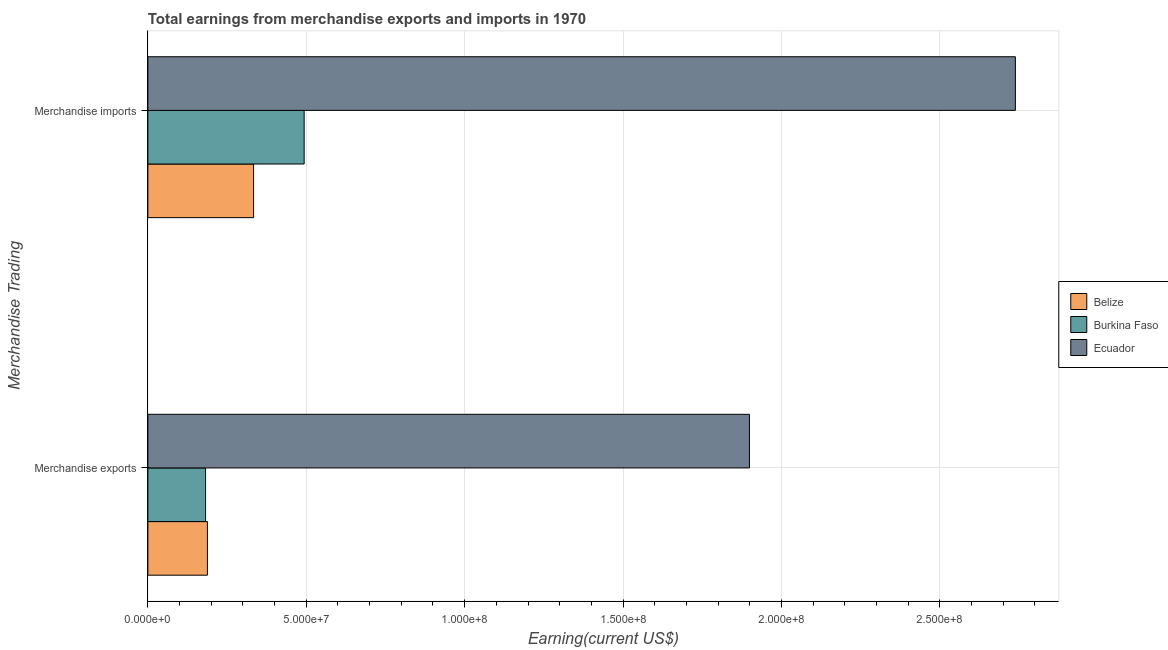How many groups of bars are there?
Make the answer very short. 2. How many bars are there on the 2nd tick from the bottom?
Provide a succinct answer. 3. What is the label of the 2nd group of bars from the top?
Provide a succinct answer. Merchandise exports. What is the earnings from merchandise imports in Ecuador?
Offer a very short reply. 2.74e+08. Across all countries, what is the maximum earnings from merchandise exports?
Offer a very short reply. 1.90e+08. Across all countries, what is the minimum earnings from merchandise exports?
Offer a very short reply. 1.82e+07. In which country was the earnings from merchandise exports maximum?
Offer a terse response. Ecuador. In which country was the earnings from merchandise exports minimum?
Your response must be concise. Burkina Faso. What is the total earnings from merchandise exports in the graph?
Provide a succinct answer. 2.27e+08. What is the difference between the earnings from merchandise imports in Belize and that in Ecuador?
Provide a short and direct response. -2.40e+08. What is the difference between the earnings from merchandise exports in Burkina Faso and the earnings from merchandise imports in Belize?
Ensure brevity in your answer.  -1.52e+07. What is the average earnings from merchandise imports per country?
Offer a very short reply. 1.19e+08. What is the difference between the earnings from merchandise imports and earnings from merchandise exports in Ecuador?
Provide a short and direct response. 8.40e+07. What is the ratio of the earnings from merchandise imports in Ecuador to that in Burkina Faso?
Give a very brief answer. 5.55. In how many countries, is the earnings from merchandise imports greater than the average earnings from merchandise imports taken over all countries?
Your answer should be compact. 1. What does the 2nd bar from the top in Merchandise exports represents?
Your answer should be compact. Burkina Faso. What does the 3rd bar from the bottom in Merchandise exports represents?
Provide a succinct answer. Ecuador. Are the values on the major ticks of X-axis written in scientific E-notation?
Give a very brief answer. Yes. What is the title of the graph?
Offer a terse response. Total earnings from merchandise exports and imports in 1970. Does "Hong Kong" appear as one of the legend labels in the graph?
Your response must be concise. No. What is the label or title of the X-axis?
Give a very brief answer. Earning(current US$). What is the label or title of the Y-axis?
Provide a short and direct response. Merchandise Trading. What is the Earning(current US$) of Belize in Merchandise exports?
Your answer should be very brief. 1.88e+07. What is the Earning(current US$) of Burkina Faso in Merchandise exports?
Provide a short and direct response. 1.82e+07. What is the Earning(current US$) in Ecuador in Merchandise exports?
Give a very brief answer. 1.90e+08. What is the Earning(current US$) of Belize in Merchandise imports?
Your answer should be very brief. 3.34e+07. What is the Earning(current US$) in Burkina Faso in Merchandise imports?
Offer a very short reply. 4.93e+07. What is the Earning(current US$) of Ecuador in Merchandise imports?
Ensure brevity in your answer.  2.74e+08. Across all Merchandise Trading, what is the maximum Earning(current US$) in Belize?
Provide a short and direct response. 3.34e+07. Across all Merchandise Trading, what is the maximum Earning(current US$) in Burkina Faso?
Keep it short and to the point. 4.93e+07. Across all Merchandise Trading, what is the maximum Earning(current US$) in Ecuador?
Your response must be concise. 2.74e+08. Across all Merchandise Trading, what is the minimum Earning(current US$) of Belize?
Give a very brief answer. 1.88e+07. Across all Merchandise Trading, what is the minimum Earning(current US$) of Burkina Faso?
Give a very brief answer. 1.82e+07. Across all Merchandise Trading, what is the minimum Earning(current US$) of Ecuador?
Provide a short and direct response. 1.90e+08. What is the total Earning(current US$) of Belize in the graph?
Provide a succinct answer. 5.22e+07. What is the total Earning(current US$) in Burkina Faso in the graph?
Ensure brevity in your answer.  6.75e+07. What is the total Earning(current US$) of Ecuador in the graph?
Make the answer very short. 4.64e+08. What is the difference between the Earning(current US$) of Belize in Merchandise exports and that in Merchandise imports?
Offer a terse response. -1.46e+07. What is the difference between the Earning(current US$) of Burkina Faso in Merchandise exports and that in Merchandise imports?
Offer a very short reply. -3.11e+07. What is the difference between the Earning(current US$) in Ecuador in Merchandise exports and that in Merchandise imports?
Provide a short and direct response. -8.40e+07. What is the difference between the Earning(current US$) in Belize in Merchandise exports and the Earning(current US$) in Burkina Faso in Merchandise imports?
Ensure brevity in your answer.  -3.05e+07. What is the difference between the Earning(current US$) of Belize in Merchandise exports and the Earning(current US$) of Ecuador in Merchandise imports?
Your answer should be very brief. -2.55e+08. What is the difference between the Earning(current US$) in Burkina Faso in Merchandise exports and the Earning(current US$) in Ecuador in Merchandise imports?
Ensure brevity in your answer.  -2.56e+08. What is the average Earning(current US$) in Belize per Merchandise Trading?
Provide a short and direct response. 2.61e+07. What is the average Earning(current US$) in Burkina Faso per Merchandise Trading?
Your answer should be compact. 3.38e+07. What is the average Earning(current US$) in Ecuador per Merchandise Trading?
Give a very brief answer. 2.32e+08. What is the difference between the Earning(current US$) of Belize and Earning(current US$) of Burkina Faso in Merchandise exports?
Give a very brief answer. 5.94e+05. What is the difference between the Earning(current US$) of Belize and Earning(current US$) of Ecuador in Merchandise exports?
Offer a terse response. -1.71e+08. What is the difference between the Earning(current US$) of Burkina Faso and Earning(current US$) of Ecuador in Merchandise exports?
Your answer should be compact. -1.72e+08. What is the difference between the Earning(current US$) of Belize and Earning(current US$) of Burkina Faso in Merchandise imports?
Your answer should be compact. -1.60e+07. What is the difference between the Earning(current US$) in Belize and Earning(current US$) in Ecuador in Merchandise imports?
Keep it short and to the point. -2.40e+08. What is the difference between the Earning(current US$) in Burkina Faso and Earning(current US$) in Ecuador in Merchandise imports?
Your answer should be compact. -2.25e+08. What is the ratio of the Earning(current US$) in Belize in Merchandise exports to that in Merchandise imports?
Keep it short and to the point. 0.56. What is the ratio of the Earning(current US$) in Burkina Faso in Merchandise exports to that in Merchandise imports?
Your answer should be very brief. 0.37. What is the ratio of the Earning(current US$) of Ecuador in Merchandise exports to that in Merchandise imports?
Your answer should be very brief. 0.69. What is the difference between the highest and the second highest Earning(current US$) of Belize?
Keep it short and to the point. 1.46e+07. What is the difference between the highest and the second highest Earning(current US$) in Burkina Faso?
Provide a succinct answer. 3.11e+07. What is the difference between the highest and the second highest Earning(current US$) in Ecuador?
Make the answer very short. 8.40e+07. What is the difference between the highest and the lowest Earning(current US$) in Belize?
Your answer should be compact. 1.46e+07. What is the difference between the highest and the lowest Earning(current US$) of Burkina Faso?
Provide a succinct answer. 3.11e+07. What is the difference between the highest and the lowest Earning(current US$) of Ecuador?
Your answer should be very brief. 8.40e+07. 